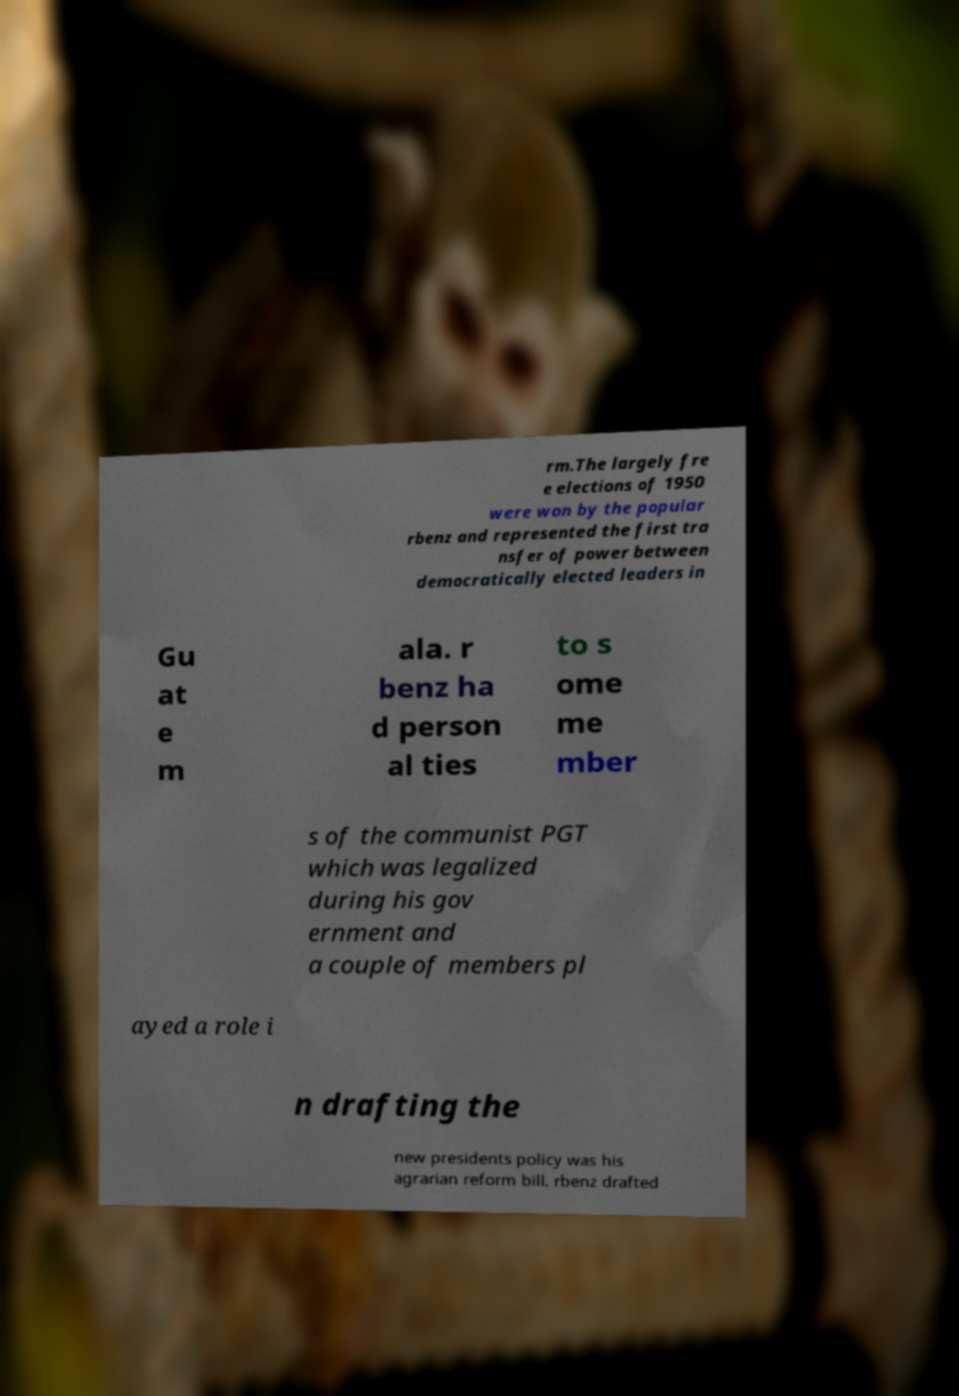Can you read and provide the text displayed in the image?This photo seems to have some interesting text. Can you extract and type it out for me? rm.The largely fre e elections of 1950 were won by the popular rbenz and represented the first tra nsfer of power between democratically elected leaders in Gu at e m ala. r benz ha d person al ties to s ome me mber s of the communist PGT which was legalized during his gov ernment and a couple of members pl ayed a role i n drafting the new presidents policy was his agrarian reform bill. rbenz drafted 